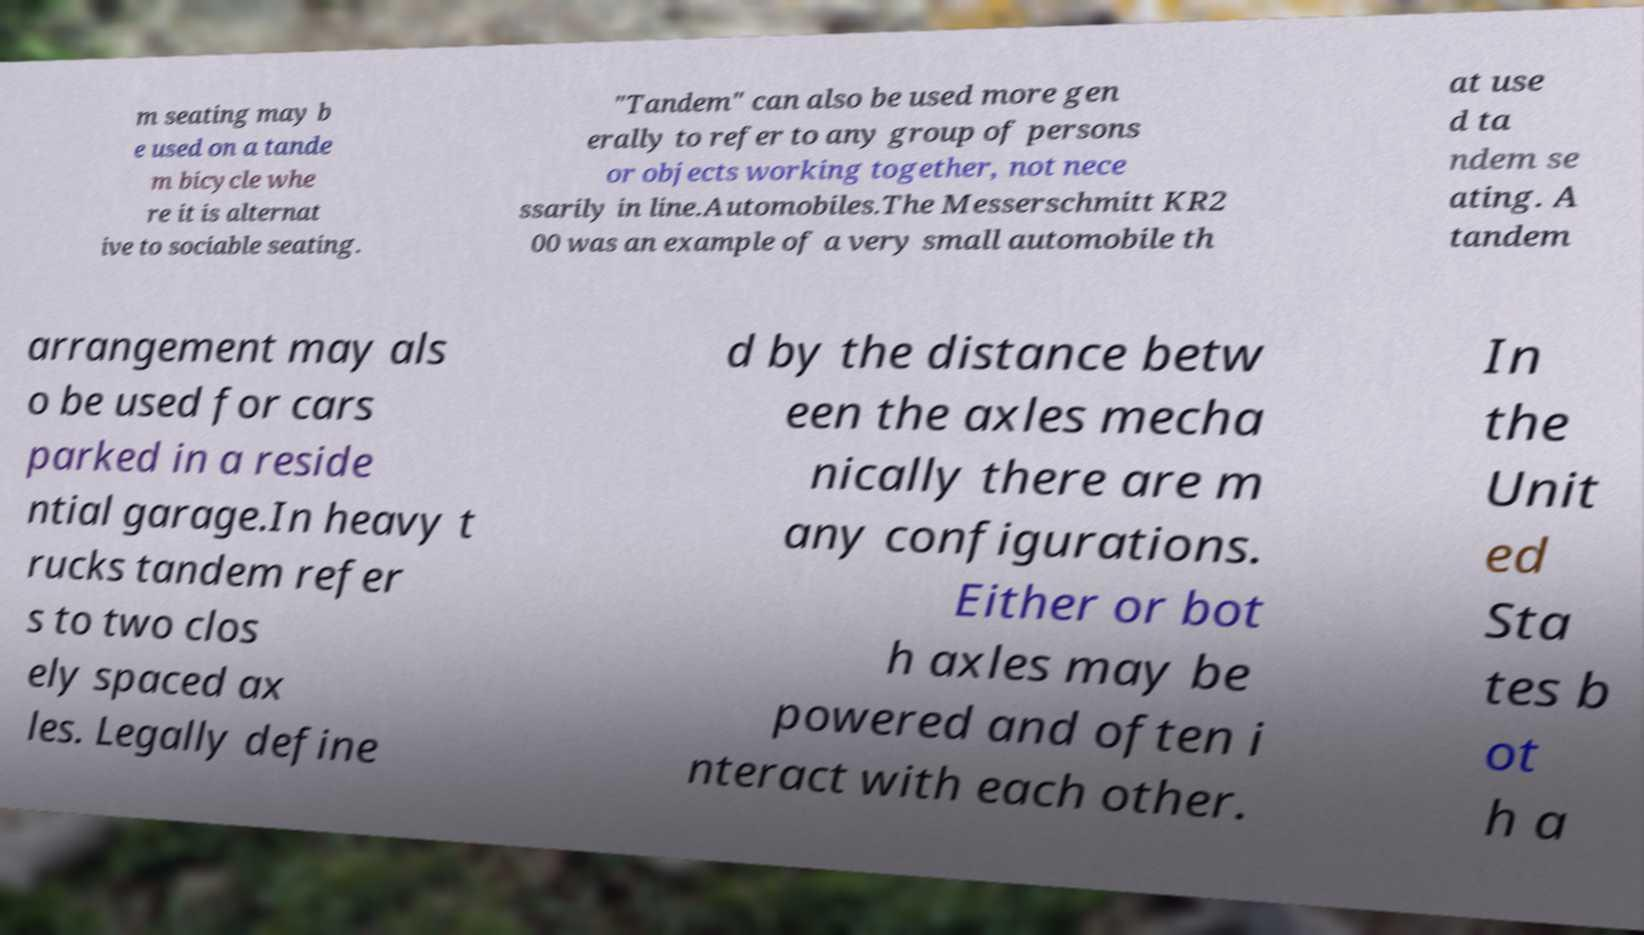I need the written content from this picture converted into text. Can you do that? m seating may b e used on a tande m bicycle whe re it is alternat ive to sociable seating. "Tandem" can also be used more gen erally to refer to any group of persons or objects working together, not nece ssarily in line.Automobiles.The Messerschmitt KR2 00 was an example of a very small automobile th at use d ta ndem se ating. A tandem arrangement may als o be used for cars parked in a reside ntial garage.In heavy t rucks tandem refer s to two clos ely spaced ax les. Legally define d by the distance betw een the axles mecha nically there are m any configurations. Either or bot h axles may be powered and often i nteract with each other. In the Unit ed Sta tes b ot h a 